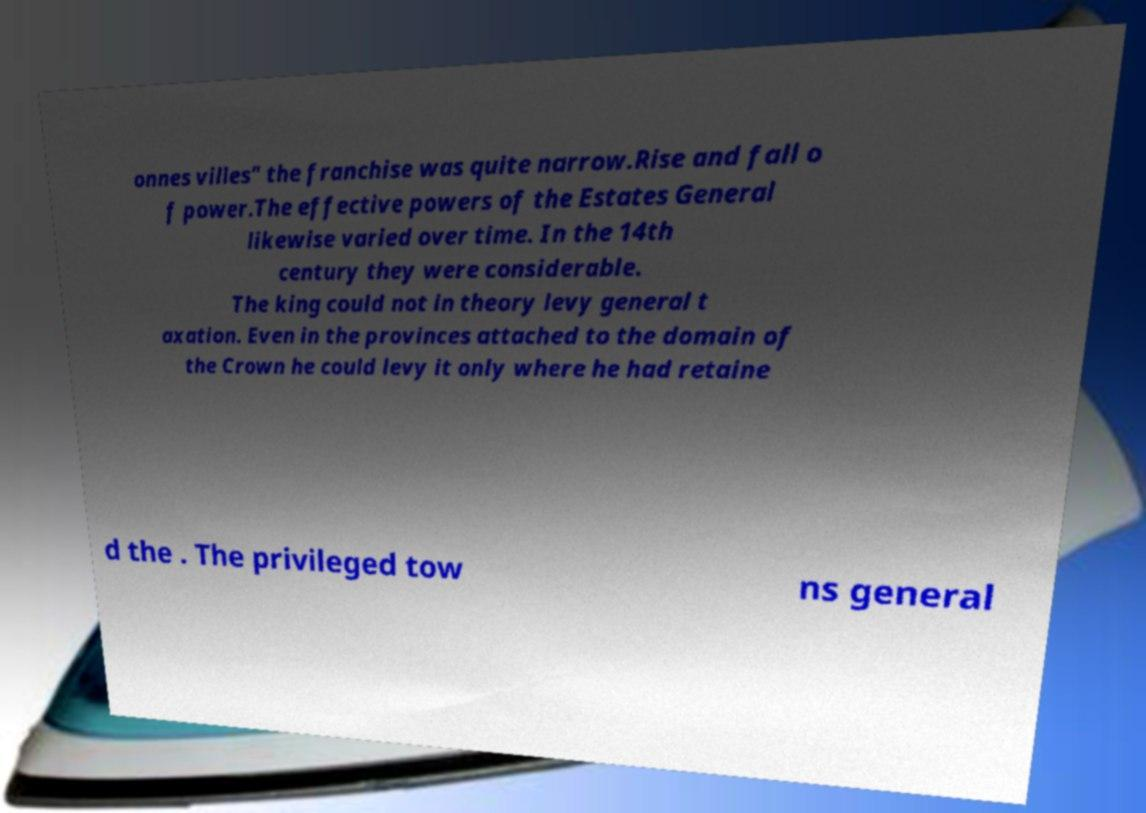There's text embedded in this image that I need extracted. Can you transcribe it verbatim? onnes villes" the franchise was quite narrow.Rise and fall o f power.The effective powers of the Estates General likewise varied over time. In the 14th century they were considerable. The king could not in theory levy general t axation. Even in the provinces attached to the domain of the Crown he could levy it only where he had retaine d the . The privileged tow ns general 